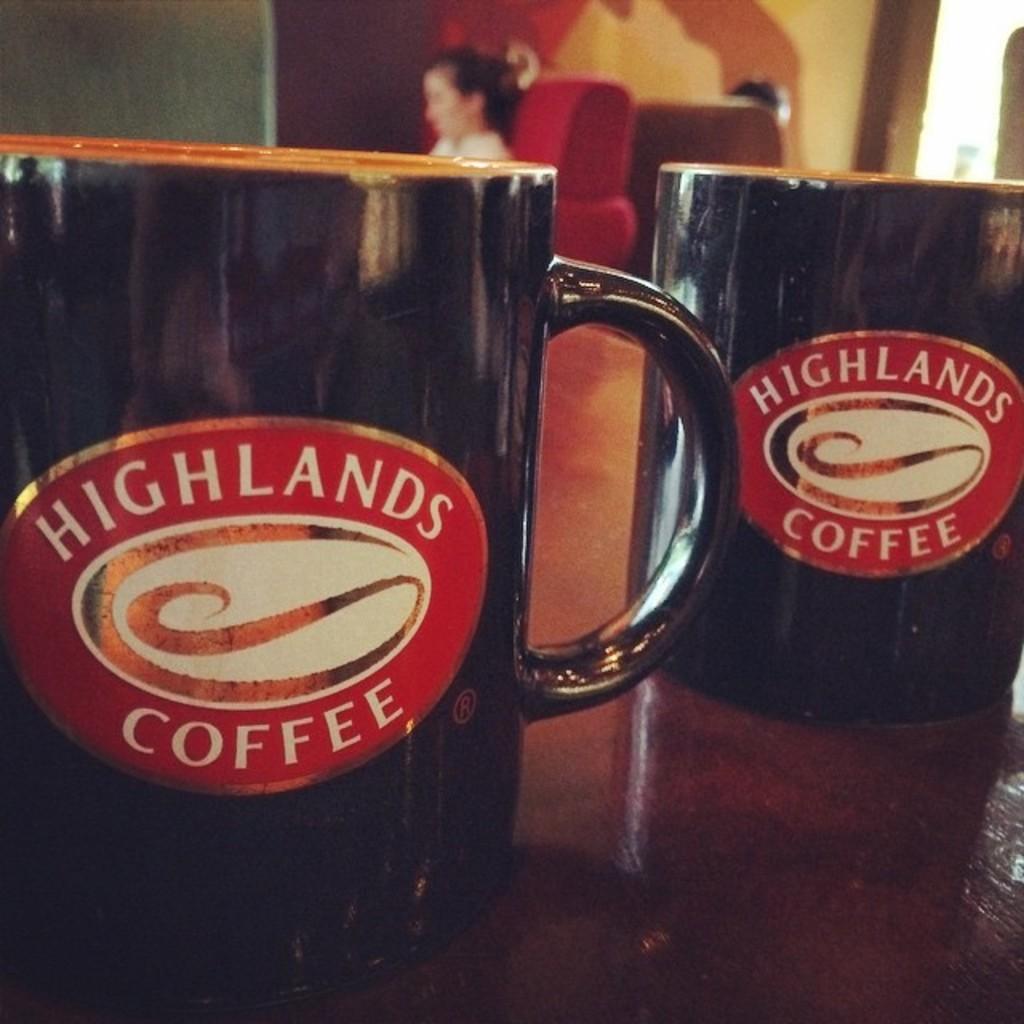Where is this coffee from?
Offer a very short reply. Highlands. 